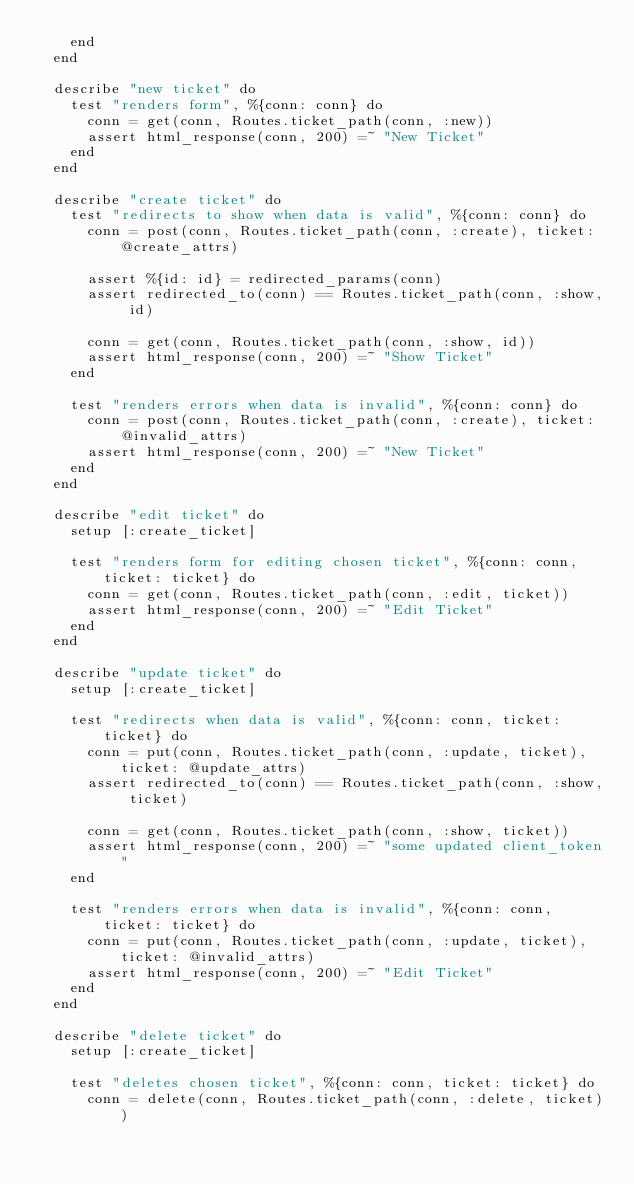Convert code to text. <code><loc_0><loc_0><loc_500><loc_500><_Elixir_>    end
  end

  describe "new ticket" do
    test "renders form", %{conn: conn} do
      conn = get(conn, Routes.ticket_path(conn, :new))
      assert html_response(conn, 200) =~ "New Ticket"
    end
  end

  describe "create ticket" do
    test "redirects to show when data is valid", %{conn: conn} do
      conn = post(conn, Routes.ticket_path(conn, :create), ticket: @create_attrs)

      assert %{id: id} = redirected_params(conn)
      assert redirected_to(conn) == Routes.ticket_path(conn, :show, id)

      conn = get(conn, Routes.ticket_path(conn, :show, id))
      assert html_response(conn, 200) =~ "Show Ticket"
    end

    test "renders errors when data is invalid", %{conn: conn} do
      conn = post(conn, Routes.ticket_path(conn, :create), ticket: @invalid_attrs)
      assert html_response(conn, 200) =~ "New Ticket"
    end
  end

  describe "edit ticket" do
    setup [:create_ticket]

    test "renders form for editing chosen ticket", %{conn: conn, ticket: ticket} do
      conn = get(conn, Routes.ticket_path(conn, :edit, ticket))
      assert html_response(conn, 200) =~ "Edit Ticket"
    end
  end

  describe "update ticket" do
    setup [:create_ticket]

    test "redirects when data is valid", %{conn: conn, ticket: ticket} do
      conn = put(conn, Routes.ticket_path(conn, :update, ticket), ticket: @update_attrs)
      assert redirected_to(conn) == Routes.ticket_path(conn, :show, ticket)

      conn = get(conn, Routes.ticket_path(conn, :show, ticket))
      assert html_response(conn, 200) =~ "some updated client_token"
    end

    test "renders errors when data is invalid", %{conn: conn, ticket: ticket} do
      conn = put(conn, Routes.ticket_path(conn, :update, ticket), ticket: @invalid_attrs)
      assert html_response(conn, 200) =~ "Edit Ticket"
    end
  end

  describe "delete ticket" do
    setup [:create_ticket]

    test "deletes chosen ticket", %{conn: conn, ticket: ticket} do
      conn = delete(conn, Routes.ticket_path(conn, :delete, ticket))</code> 